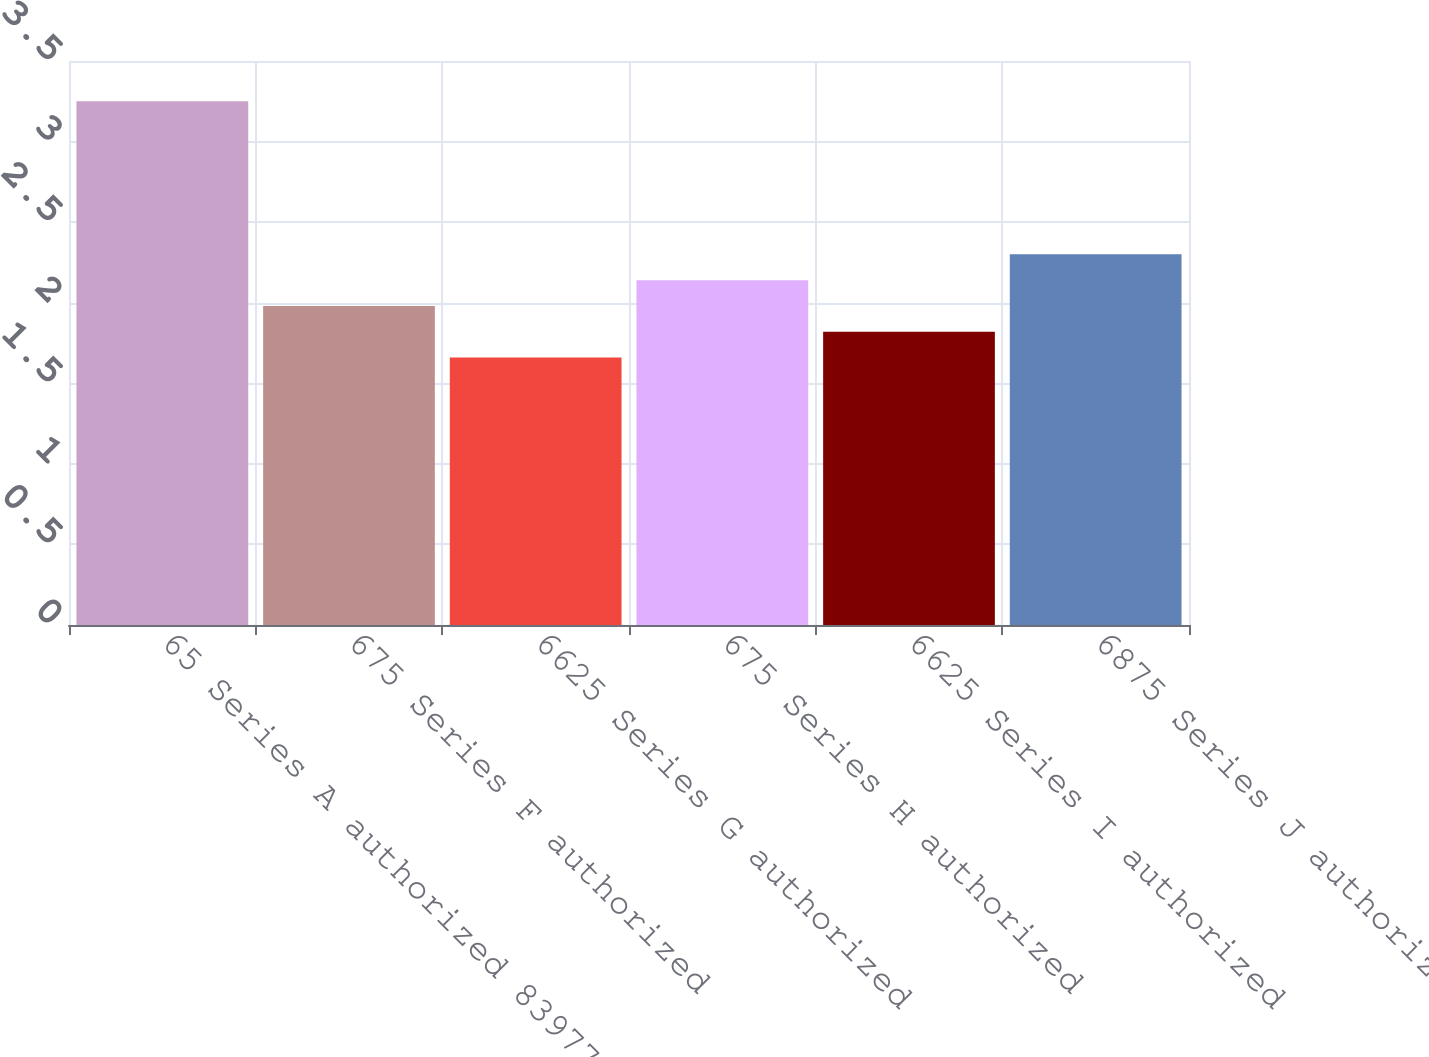<chart> <loc_0><loc_0><loc_500><loc_500><bar_chart><fcel>65 Series A authorized 83977<fcel>675 Series F authorized<fcel>6625 Series G authorized<fcel>675 Series H authorized<fcel>6625 Series I authorized<fcel>6875 Series J authorized<nl><fcel>3.25<fcel>1.98<fcel>1.66<fcel>2.14<fcel>1.82<fcel>2.3<nl></chart> 